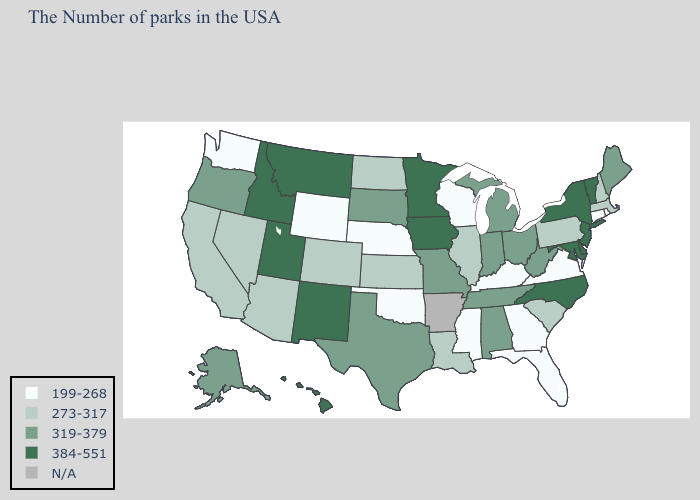Does the map have missing data?
Be succinct. Yes. What is the highest value in the MidWest ?
Give a very brief answer. 384-551. Does Delaware have the highest value in the USA?
Write a very short answer. Yes. What is the value of Iowa?
Write a very short answer. 384-551. Which states have the lowest value in the Northeast?
Keep it brief. Rhode Island, Connecticut. What is the highest value in the MidWest ?
Quick response, please. 384-551. What is the value of New Hampshire?
Answer briefly. 273-317. What is the value of Minnesota?
Be succinct. 384-551. What is the value of Alabama?
Short answer required. 319-379. Which states have the lowest value in the USA?
Answer briefly. Rhode Island, Connecticut, Virginia, Florida, Georgia, Kentucky, Wisconsin, Mississippi, Nebraska, Oklahoma, Wyoming, Washington. What is the highest value in the Northeast ?
Keep it brief. 384-551. Name the states that have a value in the range 319-379?
Concise answer only. Maine, West Virginia, Ohio, Michigan, Indiana, Alabama, Tennessee, Missouri, Texas, South Dakota, Oregon, Alaska. What is the lowest value in the South?
Be succinct. 199-268. Name the states that have a value in the range 319-379?
Quick response, please. Maine, West Virginia, Ohio, Michigan, Indiana, Alabama, Tennessee, Missouri, Texas, South Dakota, Oregon, Alaska. What is the value of Louisiana?
Answer briefly. 273-317. 